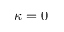Convert formula to latex. <formula><loc_0><loc_0><loc_500><loc_500>\kappa = 0</formula> 